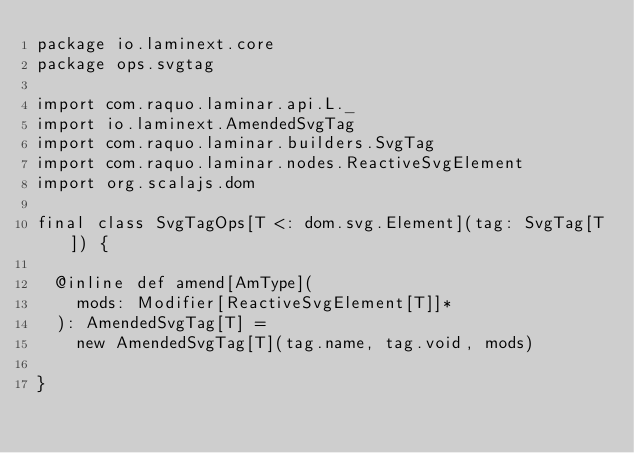Convert code to text. <code><loc_0><loc_0><loc_500><loc_500><_Scala_>package io.laminext.core
package ops.svgtag

import com.raquo.laminar.api.L._
import io.laminext.AmendedSvgTag
import com.raquo.laminar.builders.SvgTag
import com.raquo.laminar.nodes.ReactiveSvgElement
import org.scalajs.dom

final class SvgTagOps[T <: dom.svg.Element](tag: SvgTag[T]) {

  @inline def amend[AmType](
    mods: Modifier[ReactiveSvgElement[T]]*
  ): AmendedSvgTag[T] =
    new AmendedSvgTag[T](tag.name, tag.void, mods)

}
</code> 